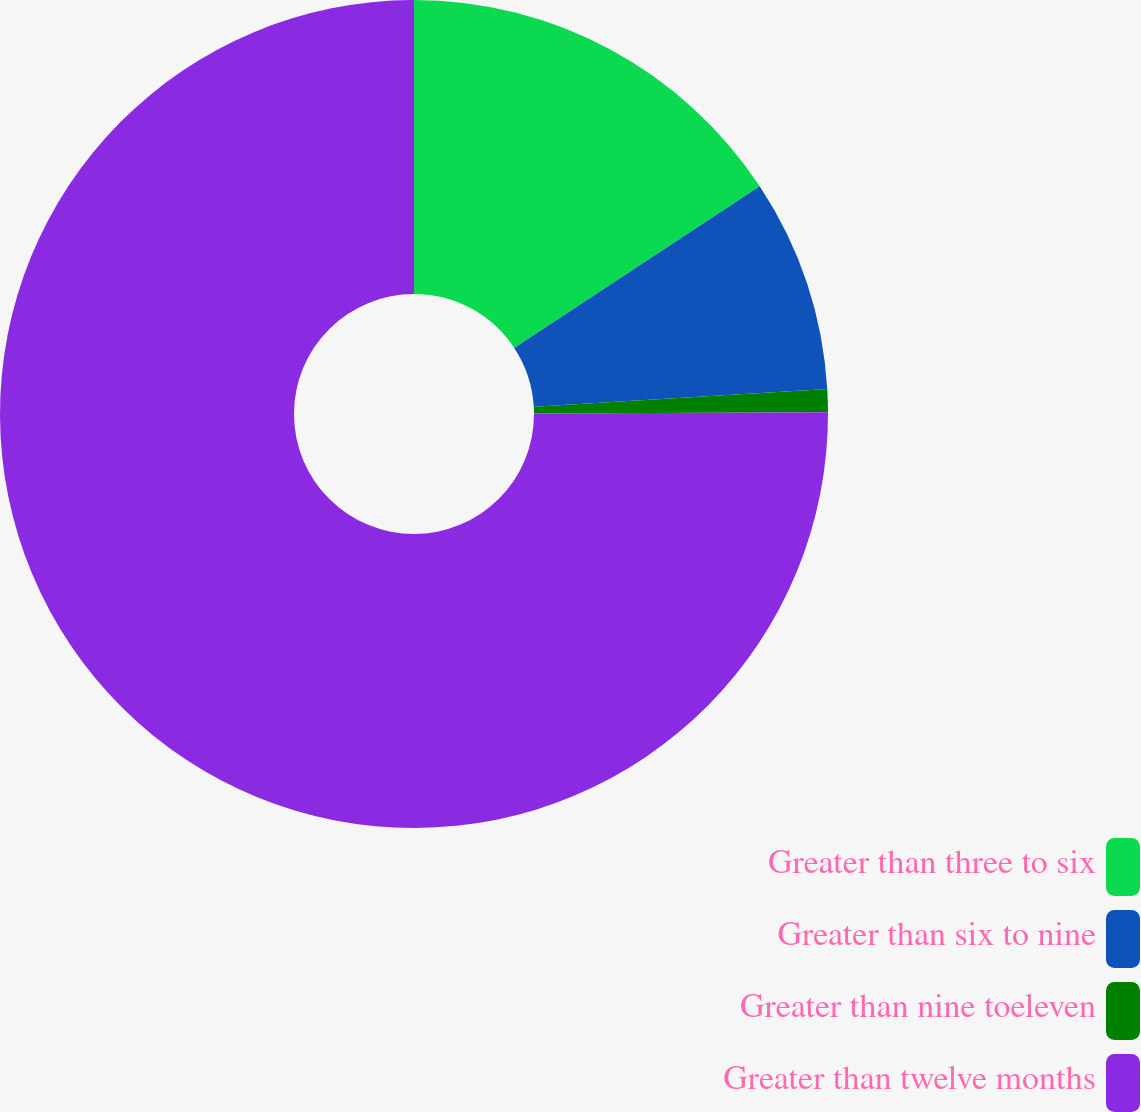Convert chart. <chart><loc_0><loc_0><loc_500><loc_500><pie_chart><fcel>Greater than three to six<fcel>Greater than six to nine<fcel>Greater than nine toeleven<fcel>Greater than twelve months<nl><fcel>15.73%<fcel>8.31%<fcel>0.89%<fcel>75.07%<nl></chart> 